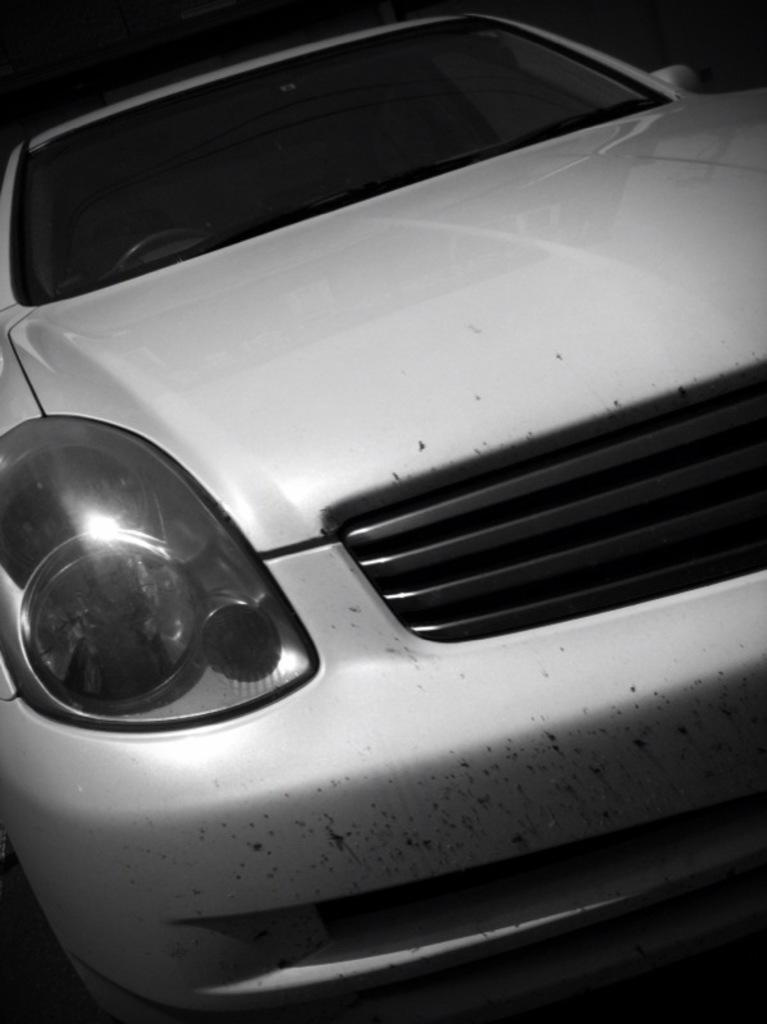What is the main subject of the image? There is a car in the center of the image. Can you describe the car in the image? The provided facts do not give any details about the car's appearance or features. Is there anything else in the image besides the car? The provided facts do not mention any other objects or subjects in the image. What type of beast is sitting in the driver's seat of the car in the image? There is no beast present in the image; it features a car in the center. What answer does the car provide to the question about the meaning of life in the image? The provided facts do not mention any questions or answers related to the meaning of life in the image. 